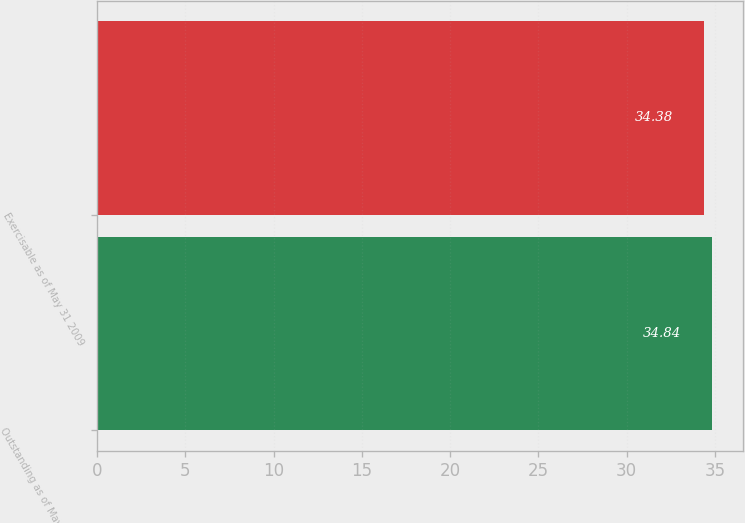<chart> <loc_0><loc_0><loc_500><loc_500><bar_chart><fcel>Outstanding as of May 31 2009<fcel>Exercisable as of May 31 2009<nl><fcel>34.84<fcel>34.38<nl></chart> 